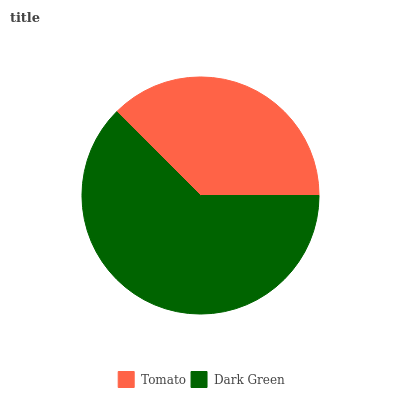Is Tomato the minimum?
Answer yes or no. Yes. Is Dark Green the maximum?
Answer yes or no. Yes. Is Dark Green the minimum?
Answer yes or no. No. Is Dark Green greater than Tomato?
Answer yes or no. Yes. Is Tomato less than Dark Green?
Answer yes or no. Yes. Is Tomato greater than Dark Green?
Answer yes or no. No. Is Dark Green less than Tomato?
Answer yes or no. No. Is Dark Green the high median?
Answer yes or no. Yes. Is Tomato the low median?
Answer yes or no. Yes. Is Tomato the high median?
Answer yes or no. No. Is Dark Green the low median?
Answer yes or no. No. 